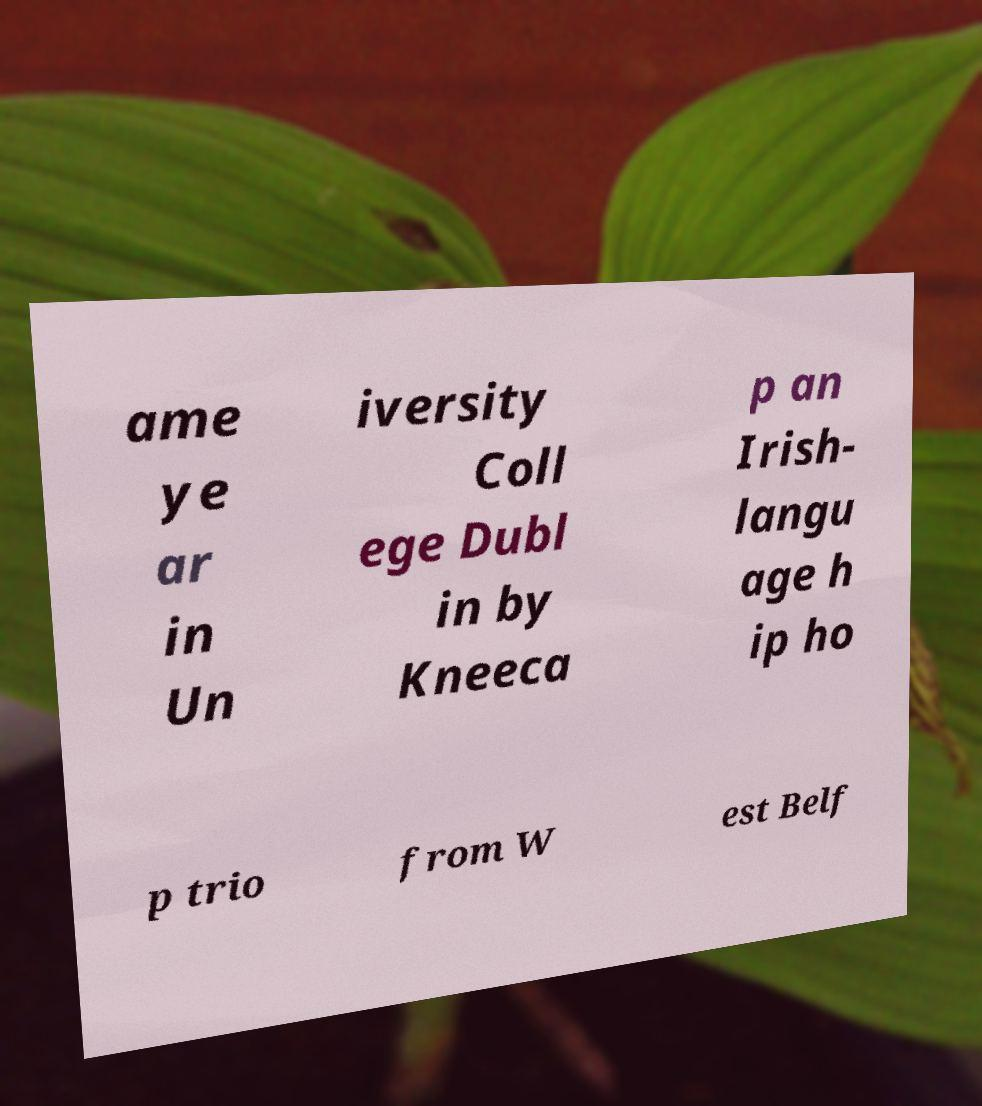What messages or text are displayed in this image? I need them in a readable, typed format. ame ye ar in Un iversity Coll ege Dubl in by Kneeca p an Irish- langu age h ip ho p trio from W est Belf 